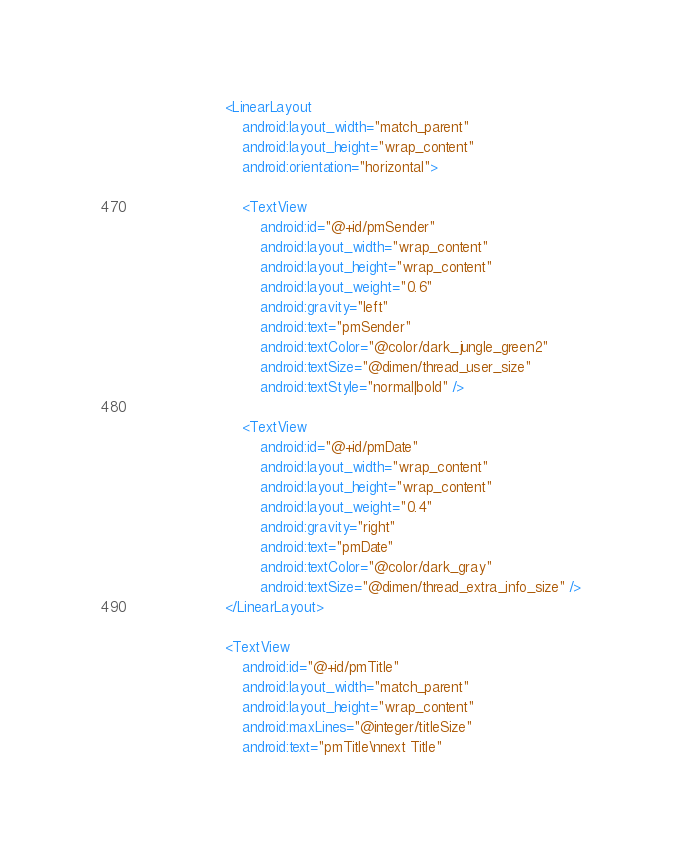Convert code to text. <code><loc_0><loc_0><loc_500><loc_500><_XML_>
                    <LinearLayout
                        android:layout_width="match_parent"
                        android:layout_height="wrap_content"
                        android:orientation="horizontal">

                        <TextView
                            android:id="@+id/pmSender"
                            android:layout_width="wrap_content"
                            android:layout_height="wrap_content"
                            android:layout_weight="0.6"
                            android:gravity="left"
                            android:text="pmSender"
                            android:textColor="@color/dark_jungle_green2"
                            android:textSize="@dimen/thread_user_size"
                            android:textStyle="normal|bold" />

                        <TextView
                            android:id="@+id/pmDate"
                            android:layout_width="wrap_content"
                            android:layout_height="wrap_content"
                            android:layout_weight="0.4"
                            android:gravity="right"
                            android:text="pmDate"
                            android:textColor="@color/dark_gray"
                            android:textSize="@dimen/thread_extra_info_size" />
                    </LinearLayout>

                    <TextView
                        android:id="@+id/pmTitle"
                        android:layout_width="match_parent"
                        android:layout_height="wrap_content"
                        android:maxLines="@integer/titleSize"
                        android:text="pmTitle\nnext Title"</code> 